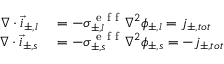<formula> <loc_0><loc_0><loc_500><loc_500>\begin{array} { r l } { \nabla \cdot \vec { i } _ { \pm , l } } & = - \sigma _ { \pm , l } ^ { e f f } \nabla ^ { 2 } \phi _ { \pm , l } = j _ { \pm , t o t } } \\ { \nabla \cdot \vec { i } _ { \pm , s } } & = - \sigma _ { \pm , s } ^ { e f f } \nabla ^ { 2 } \phi _ { \pm , s } = - j _ { \pm , t o t } } \end{array}</formula> 